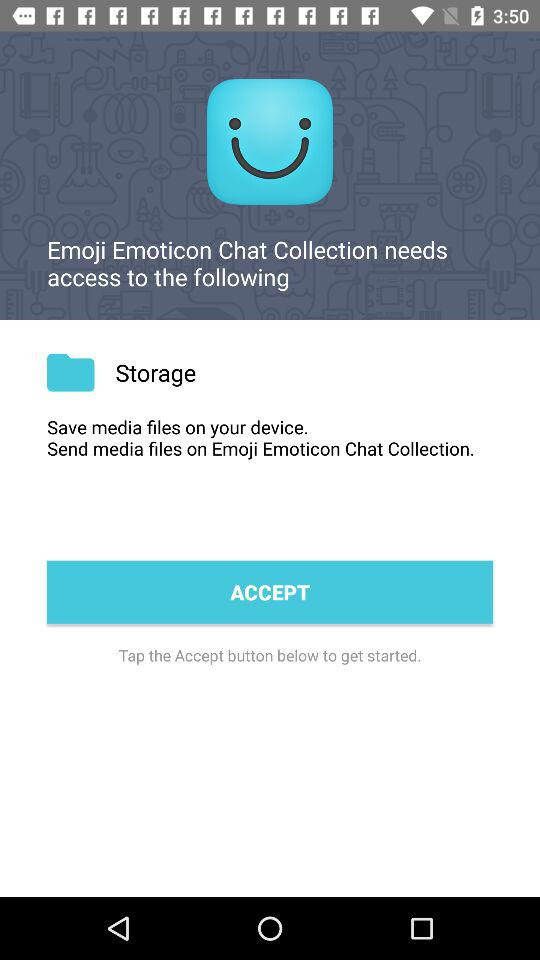What app needs access? The app that needs access is "Emoji Emoticon Chat Collection". 